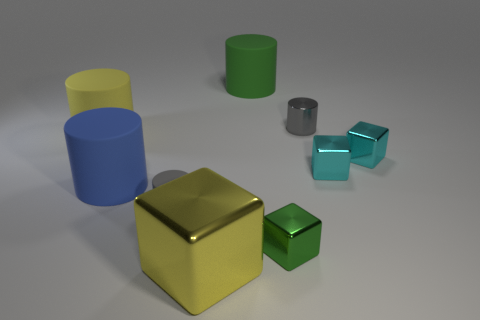How many gray cylinders must be subtracted to get 1 gray cylinders? 1 Subtract all big yellow blocks. How many blocks are left? 3 Subtract all brown cubes. How many gray cylinders are left? 2 Subtract all blue cylinders. How many cylinders are left? 4 Subtract 2 blocks. How many blocks are left? 2 Subtract all cylinders. How many objects are left? 4 Subtract all large yellow matte things. Subtract all small gray things. How many objects are left? 6 Add 4 small things. How many small things are left? 9 Add 6 gray cylinders. How many gray cylinders exist? 8 Subtract 0 cyan cylinders. How many objects are left? 9 